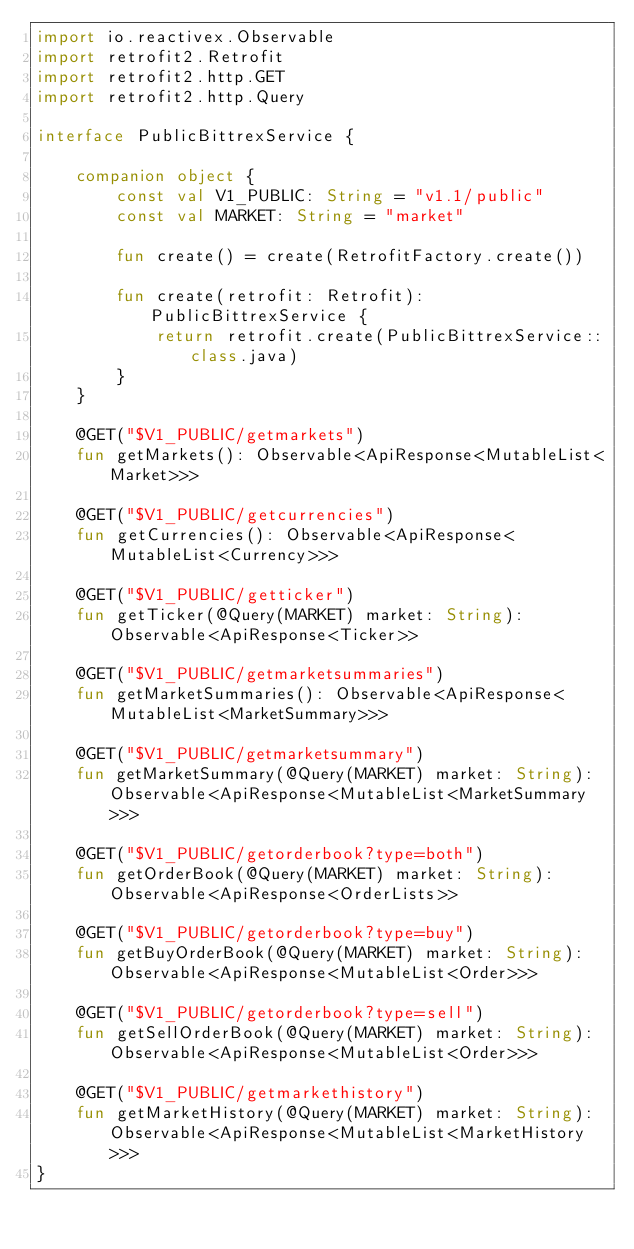<code> <loc_0><loc_0><loc_500><loc_500><_Kotlin_>import io.reactivex.Observable
import retrofit2.Retrofit
import retrofit2.http.GET
import retrofit2.http.Query

interface PublicBittrexService {

    companion object {
        const val V1_PUBLIC: String = "v1.1/public"
        const val MARKET: String = "market"

        fun create() = create(RetrofitFactory.create())

        fun create(retrofit: Retrofit): PublicBittrexService {
            return retrofit.create(PublicBittrexService::class.java)
        }
    }

    @GET("$V1_PUBLIC/getmarkets")
    fun getMarkets(): Observable<ApiResponse<MutableList<Market>>>

    @GET("$V1_PUBLIC/getcurrencies")
    fun getCurrencies(): Observable<ApiResponse<MutableList<Currency>>>

    @GET("$V1_PUBLIC/getticker")
    fun getTicker(@Query(MARKET) market: String): Observable<ApiResponse<Ticker>>

    @GET("$V1_PUBLIC/getmarketsummaries")
    fun getMarketSummaries(): Observable<ApiResponse<MutableList<MarketSummary>>>

    @GET("$V1_PUBLIC/getmarketsummary")
    fun getMarketSummary(@Query(MARKET) market: String): Observable<ApiResponse<MutableList<MarketSummary>>>

    @GET("$V1_PUBLIC/getorderbook?type=both")
    fun getOrderBook(@Query(MARKET) market: String): Observable<ApiResponse<OrderLists>>

    @GET("$V1_PUBLIC/getorderbook?type=buy")
    fun getBuyOrderBook(@Query(MARKET) market: String): Observable<ApiResponse<MutableList<Order>>>

    @GET("$V1_PUBLIC/getorderbook?type=sell")
    fun getSellOrderBook(@Query(MARKET) market: String): Observable<ApiResponse<MutableList<Order>>>

    @GET("$V1_PUBLIC/getmarkethistory")
    fun getMarketHistory(@Query(MARKET) market: String): Observable<ApiResponse<MutableList<MarketHistory>>>
}</code> 